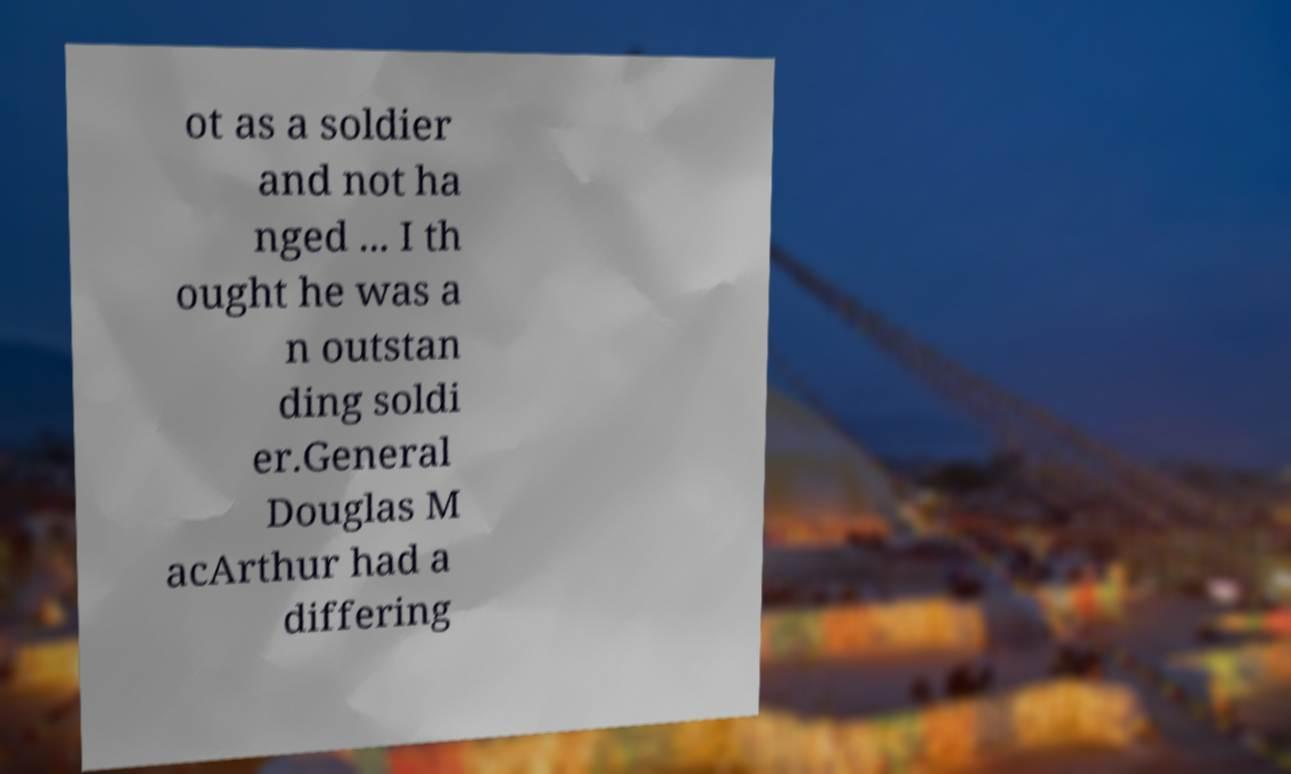I need the written content from this picture converted into text. Can you do that? ot as a soldier and not ha nged ... I th ought he was a n outstan ding soldi er.General Douglas M acArthur had a differing 